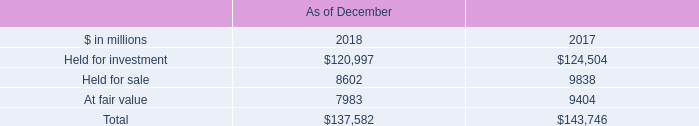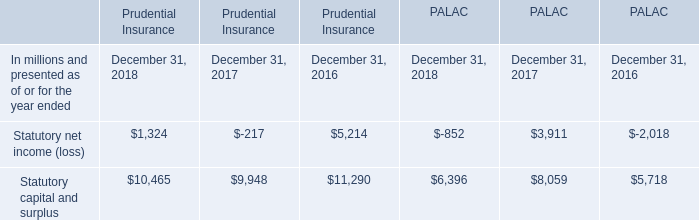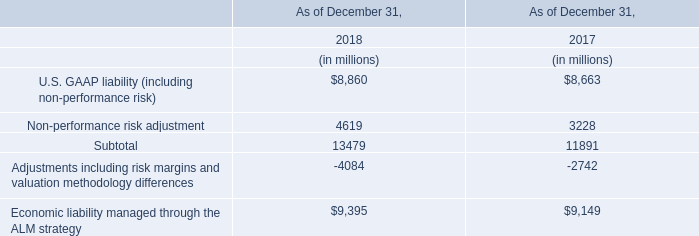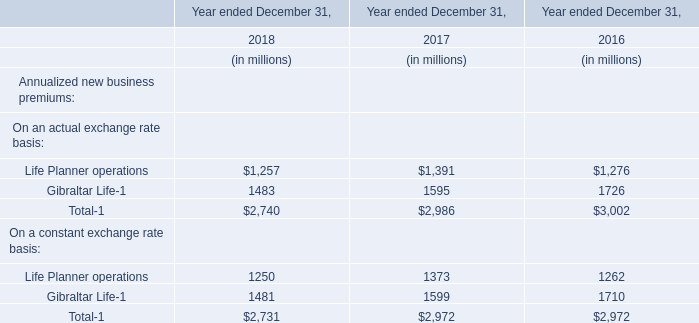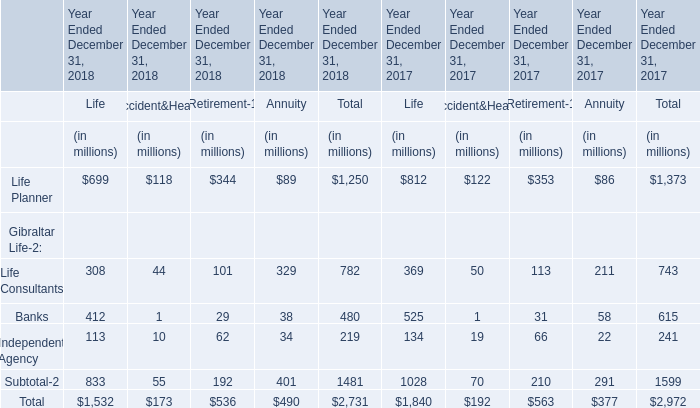What is the average value of Total-1 in 2018,2017 and 2016 ? (in million) 
Computations: (((2740 + 2986) + 3002) / 3)
Answer: 2909.33333. 